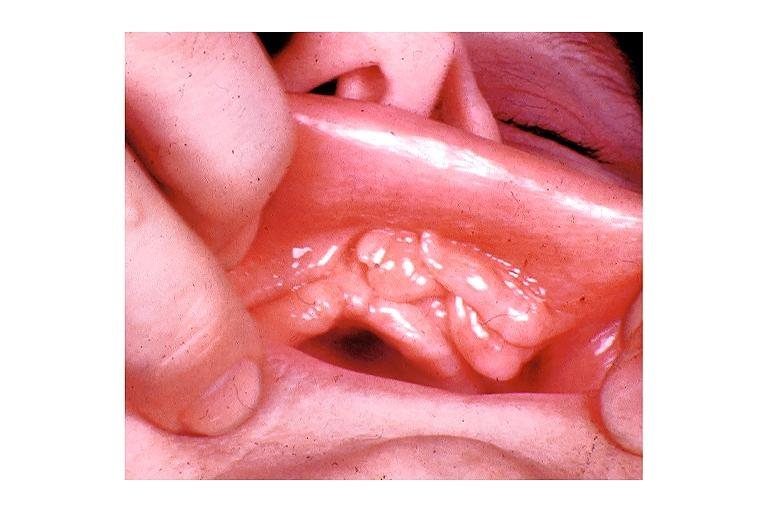does this image show epulis fissuratum?
Answer the question using a single word or phrase. Yes 